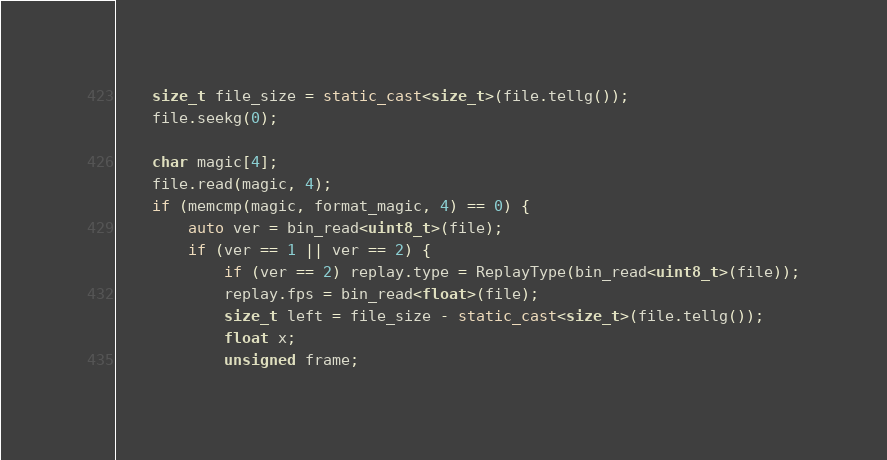Convert code to text. <code><loc_0><loc_0><loc_500><loc_500><_C++_>	size_t file_size = static_cast<size_t>(file.tellg());
	file.seekg(0);

	char magic[4];
	file.read(magic, 4);
	if (memcmp(magic, format_magic, 4) == 0) {
		auto ver = bin_read<uint8_t>(file);
		if (ver == 1 || ver == 2) {
			if (ver == 2) replay.type = ReplayType(bin_read<uint8_t>(file));
			replay.fps = bin_read<float>(file);
			size_t left = file_size - static_cast<size_t>(file.tellg());
			float x;
			unsigned frame;</code> 